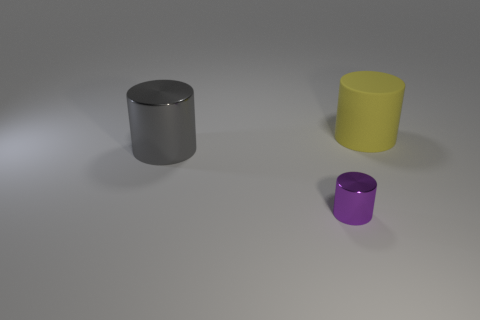What material is the cylinder that is behind the big cylinder to the left of the yellow thing?
Make the answer very short. Rubber. The yellow thing has what size?
Your answer should be very brief. Large. What number of purple things have the same size as the yellow matte thing?
Ensure brevity in your answer.  0. How many big gray shiny things have the same shape as the yellow matte thing?
Provide a succinct answer. 1. Are there an equal number of large cylinders in front of the matte cylinder and tiny things?
Your answer should be compact. Yes. Is there any other thing that has the same size as the purple shiny object?
Your response must be concise. No. There is a yellow thing that is the same size as the gray shiny thing; what is its shape?
Offer a terse response. Cylinder. Is there a small purple shiny object that has the same shape as the big gray thing?
Make the answer very short. Yes. There is a metal cylinder that is on the right side of the thing that is left of the purple object; are there any large gray metallic objects that are behind it?
Offer a very short reply. Yes. Are there more purple shiny cylinders in front of the large gray cylinder than yellow matte cylinders behind the yellow cylinder?
Ensure brevity in your answer.  Yes. 